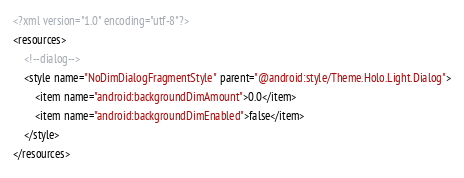<code> <loc_0><loc_0><loc_500><loc_500><_XML_><?xml version="1.0" encoding="utf-8"?>
<resources>
    <!--dialog-->
    <style name="NoDimDialogFragmentStyle" parent="@android:style/Theme.Holo.Light.Dialog">
        <item name="android:backgroundDimAmount">0.0</item>
        <item name="android:backgroundDimEnabled">false</item>
    </style>
</resources></code> 